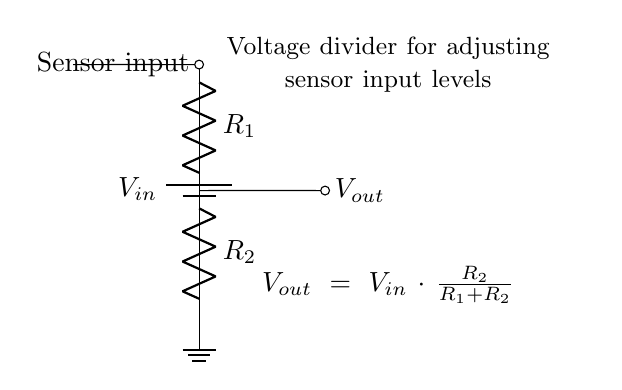What is the source voltage in this circuit? The source voltage is labeled as V in and represents the input voltage for the voltage divider circuit.
Answer: V in What are the resistor values in the voltage divider? The resistors are labeled as R 1 and R 2, which are the two resistors of the voltage divider.
Answer: R 1, R 2 What is the output voltage equation for this circuit? The output voltage is given by the formula V out equals V in multiplied by the fraction R 2 over the sum of R 1 and R 2.
Answer: V out = V in * (R 2 / (R 1 + R 2)) How does increasing R 2 affect V out? Increasing R 2 raises the output voltage V out because it increases the fraction of V in that is divided across R 2, making V out closer to V in.
Answer: Increases V out What happens to V out if R 1 is decreased while R 2 is constant? Decreasing R 1 will lead to an increase in the overall resistance in the denominator of the voltage divider equation, which in turn will increase V out.
Answer: Increases V out What is the function of the voltage divider in this circuit? The voltage divider adjusts the sensor input levels by scaling down the voltage according to the values of R 1 and R 2 before it reaches the sensor.
Answer: Adjust sensor input levels 